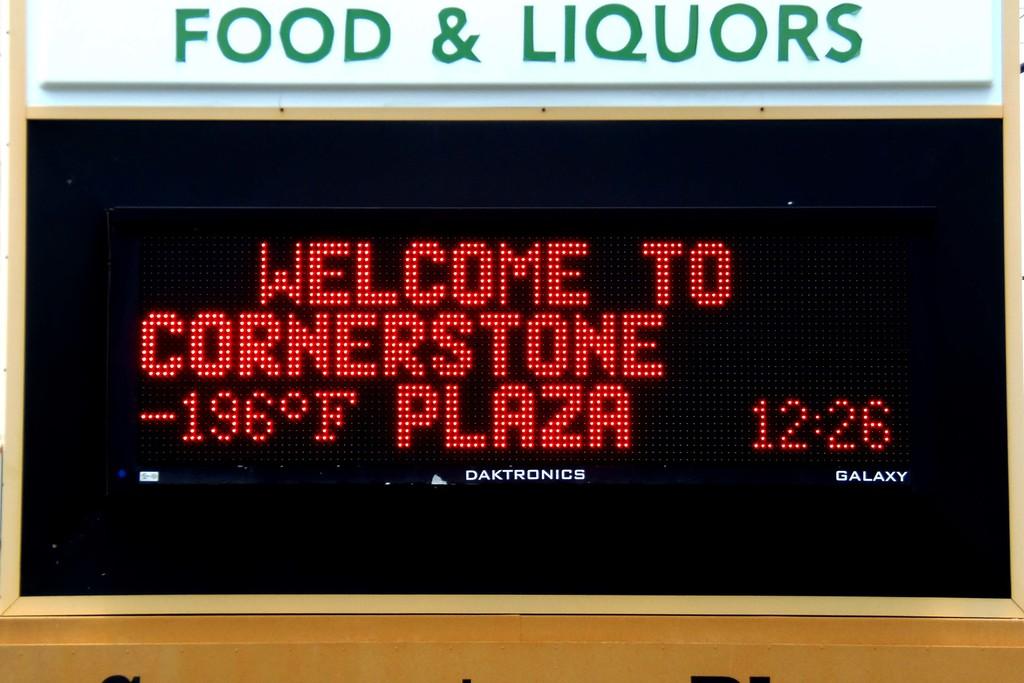What is the name of the plaza?
Your answer should be compact. Cornerstone plaza. What time is it?
Keep it short and to the point. 12:26. 